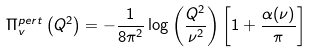Convert formula to latex. <formula><loc_0><loc_0><loc_500><loc_500>\Pi ^ { p e r t } _ { v } \left ( Q ^ { 2 } \right ) = - \frac { 1 } { 8 \pi ^ { 2 } } \log { \left ( \frac { Q ^ { 2 } } { \nu ^ { 2 } } \right ) } \left [ 1 + \frac { \alpha ( \nu ) } { \pi } \right ]</formula> 